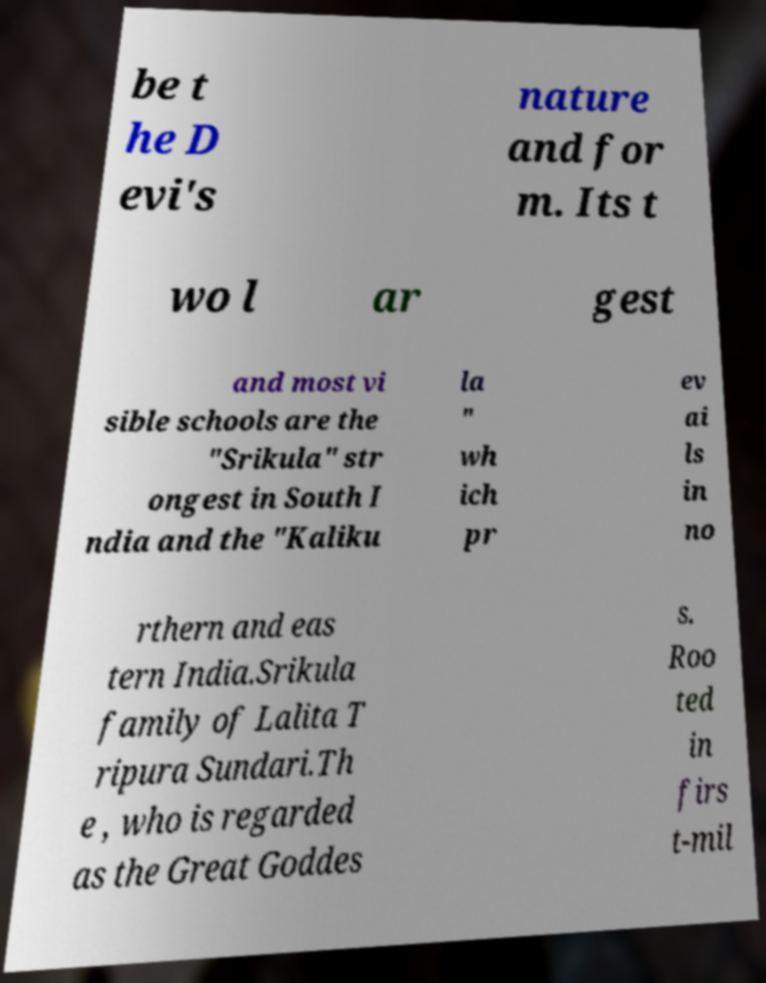What messages or text are displayed in this image? I need them in a readable, typed format. be t he D evi's nature and for m. Its t wo l ar gest and most vi sible schools are the "Srikula" str ongest in South I ndia and the "Kaliku la " wh ich pr ev ai ls in no rthern and eas tern India.Srikula family of Lalita T ripura Sundari.Th e , who is regarded as the Great Goddes s. Roo ted in firs t-mil 